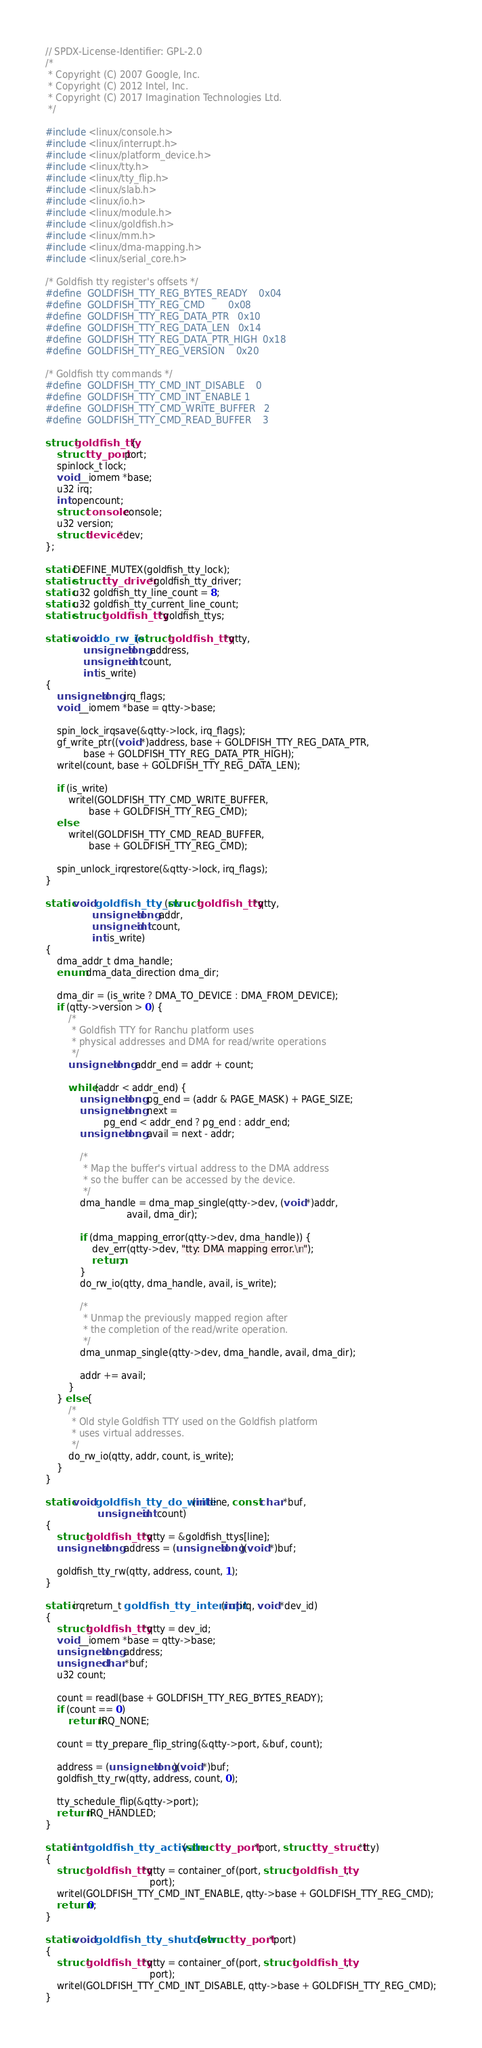<code> <loc_0><loc_0><loc_500><loc_500><_C_>// SPDX-License-Identifier: GPL-2.0
/*
 * Copyright (C) 2007 Google, Inc.
 * Copyright (C) 2012 Intel, Inc.
 * Copyright (C) 2017 Imagination Technologies Ltd.
 */

#include <linux/console.h>
#include <linux/interrupt.h>
#include <linux/platform_device.h>
#include <linux/tty.h>
#include <linux/tty_flip.h>
#include <linux/slab.h>
#include <linux/io.h>
#include <linux/module.h>
#include <linux/goldfish.h>
#include <linux/mm.h>
#include <linux/dma-mapping.h>
#include <linux/serial_core.h>

/* Goldfish tty register's offsets */
#define	GOLDFISH_TTY_REG_BYTES_READY	0x04
#define	GOLDFISH_TTY_REG_CMD		0x08
#define	GOLDFISH_TTY_REG_DATA_PTR	0x10
#define	GOLDFISH_TTY_REG_DATA_LEN	0x14
#define	GOLDFISH_TTY_REG_DATA_PTR_HIGH	0x18
#define	GOLDFISH_TTY_REG_VERSION	0x20

/* Goldfish tty commands */
#define	GOLDFISH_TTY_CMD_INT_DISABLE	0
#define	GOLDFISH_TTY_CMD_INT_ENABLE	1
#define	GOLDFISH_TTY_CMD_WRITE_BUFFER	2
#define	GOLDFISH_TTY_CMD_READ_BUFFER	3

struct goldfish_tty {
	struct tty_port port;
	spinlock_t lock;
	void __iomem *base;
	u32 irq;
	int opencount;
	struct console console;
	u32 version;
	struct device *dev;
};

static DEFINE_MUTEX(goldfish_tty_lock);
static struct tty_driver *goldfish_tty_driver;
static u32 goldfish_tty_line_count = 8;
static u32 goldfish_tty_current_line_count;
static struct goldfish_tty *goldfish_ttys;

static void do_rw_io(struct goldfish_tty *qtty,
		     unsigned long address,
		     unsigned int count,
		     int is_write)
{
	unsigned long irq_flags;
	void __iomem *base = qtty->base;

	spin_lock_irqsave(&qtty->lock, irq_flags);
	gf_write_ptr((void *)address, base + GOLDFISH_TTY_REG_DATA_PTR,
		     base + GOLDFISH_TTY_REG_DATA_PTR_HIGH);
	writel(count, base + GOLDFISH_TTY_REG_DATA_LEN);

	if (is_write)
		writel(GOLDFISH_TTY_CMD_WRITE_BUFFER,
		       base + GOLDFISH_TTY_REG_CMD);
	else
		writel(GOLDFISH_TTY_CMD_READ_BUFFER,
		       base + GOLDFISH_TTY_REG_CMD);

	spin_unlock_irqrestore(&qtty->lock, irq_flags);
}

static void goldfish_tty_rw(struct goldfish_tty *qtty,
			    unsigned long addr,
			    unsigned int count,
			    int is_write)
{
	dma_addr_t dma_handle;
	enum dma_data_direction dma_dir;

	dma_dir = (is_write ? DMA_TO_DEVICE : DMA_FROM_DEVICE);
	if (qtty->version > 0) {
		/*
		 * Goldfish TTY for Ranchu platform uses
		 * physical addresses and DMA for read/write operations
		 */
		unsigned long addr_end = addr + count;

		while (addr < addr_end) {
			unsigned long pg_end = (addr & PAGE_MASK) + PAGE_SIZE;
			unsigned long next =
					pg_end < addr_end ? pg_end : addr_end;
			unsigned long avail = next - addr;

			/*
			 * Map the buffer's virtual address to the DMA address
			 * so the buffer can be accessed by the device.
			 */
			dma_handle = dma_map_single(qtty->dev, (void *)addr,
						    avail, dma_dir);

			if (dma_mapping_error(qtty->dev, dma_handle)) {
				dev_err(qtty->dev, "tty: DMA mapping error.\n");
				return;
			}
			do_rw_io(qtty, dma_handle, avail, is_write);

			/*
			 * Unmap the previously mapped region after
			 * the completion of the read/write operation.
			 */
			dma_unmap_single(qtty->dev, dma_handle, avail, dma_dir);

			addr += avail;
		}
	} else {
		/*
		 * Old style Goldfish TTY used on the Goldfish platform
		 * uses virtual addresses.
		 */
		do_rw_io(qtty, addr, count, is_write);
	}
}

static void goldfish_tty_do_write(int line, const char *buf,
				  unsigned int count)
{
	struct goldfish_tty *qtty = &goldfish_ttys[line];
	unsigned long address = (unsigned long)(void *)buf;

	goldfish_tty_rw(qtty, address, count, 1);
}

static irqreturn_t goldfish_tty_interrupt(int irq, void *dev_id)
{
	struct goldfish_tty *qtty = dev_id;
	void __iomem *base = qtty->base;
	unsigned long address;
	unsigned char *buf;
	u32 count;

	count = readl(base + GOLDFISH_TTY_REG_BYTES_READY);
	if (count == 0)
		return IRQ_NONE;

	count = tty_prepare_flip_string(&qtty->port, &buf, count);

	address = (unsigned long)(void *)buf;
	goldfish_tty_rw(qtty, address, count, 0);

	tty_schedule_flip(&qtty->port);
	return IRQ_HANDLED;
}

static int goldfish_tty_activate(struct tty_port *port, struct tty_struct *tty)
{
	struct goldfish_tty *qtty = container_of(port, struct goldfish_tty,
									port);
	writel(GOLDFISH_TTY_CMD_INT_ENABLE, qtty->base + GOLDFISH_TTY_REG_CMD);
	return 0;
}

static void goldfish_tty_shutdown(struct tty_port *port)
{
	struct goldfish_tty *qtty = container_of(port, struct goldfish_tty,
									port);
	writel(GOLDFISH_TTY_CMD_INT_DISABLE, qtty->base + GOLDFISH_TTY_REG_CMD);
}
</code> 